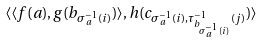Convert formula to latex. <formula><loc_0><loc_0><loc_500><loc_500>\langle \langle f ( a ) , g ( b _ { \sigma _ { a } ^ { - 1 } ( i ) } ) \rangle , h ( c _ { \sigma _ { a } ^ { - 1 } ( i ) , \tau _ { b _ { \sigma _ { a } ^ { - 1 } ( i ) } } ^ { - 1 } ( j ) } ) \rangle</formula> 